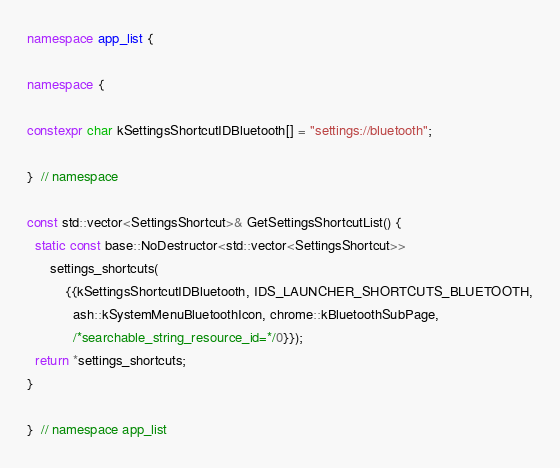<code> <loc_0><loc_0><loc_500><loc_500><_C++_>
namespace app_list {

namespace {

constexpr char kSettingsShortcutIDBluetooth[] = "settings://bluetooth";

}  // namespace

const std::vector<SettingsShortcut>& GetSettingsShortcutList() {
  static const base::NoDestructor<std::vector<SettingsShortcut>>
      settings_shortcuts(
          {{kSettingsShortcutIDBluetooth, IDS_LAUNCHER_SHORTCUTS_BLUETOOTH,
            ash::kSystemMenuBluetoothIcon, chrome::kBluetoothSubPage,
            /*searchable_string_resource_id=*/0}});
  return *settings_shortcuts;
}

}  // namespace app_list
</code> 